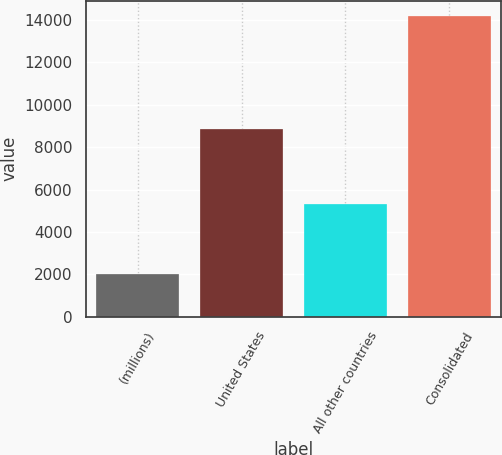Convert chart. <chart><loc_0><loc_0><loc_500><loc_500><bar_chart><fcel>(millions)<fcel>United States<fcel>All other countries<fcel>Consolidated<nl><fcel>2012<fcel>8875<fcel>5322<fcel>14197<nl></chart> 